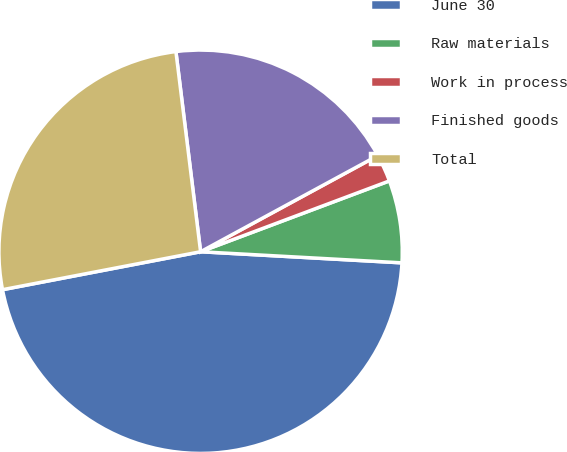Convert chart to OTSL. <chart><loc_0><loc_0><loc_500><loc_500><pie_chart><fcel>June 30<fcel>Raw materials<fcel>Work in process<fcel>Finished goods<fcel>Total<nl><fcel>46.11%<fcel>6.59%<fcel>2.2%<fcel>19.04%<fcel>26.06%<nl></chart> 